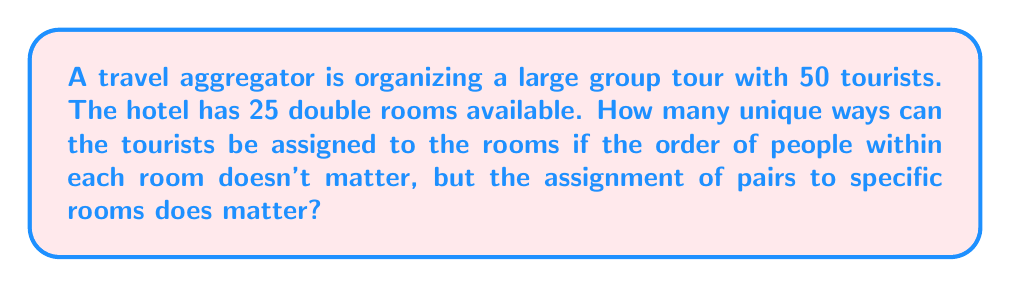Can you solve this math problem? Let's approach this step-by-step:

1) First, we need to determine how many ways we can pair up the 50 tourists. This is equivalent to choosing 25 pairs from 50 people.

2) To calculate this, we use the following formula:
   $$\frac{50!}{(2!)^{25} \cdot 25!}$$

   Where:
   - 50! represents all possible arrangements of 50 people
   - $(2!)^{25}$ accounts for the fact that the order within each pair doesn't matter
   - 25! accounts for the fact that the order of selecting the pairs doesn't matter

3) Next, we need to consider that these 25 pairs can be assigned to the 25 rooms in 25! ways.

4) Therefore, the total number of unique assignments is:

   $$\frac{50!}{(2!)^{25} \cdot 25!} \cdot 25!$$

5) This simplifies to:

   $$\frac{50!}{(2!)^{25}}$$

6) Calculating this:
   
   $$\frac{50!}{(2)^{25}} = 7.04 \times 10^{47}$$

This enormous number represents the total number of unique ways to assign 50 tourists to 25 double rooms, considering the specified conditions.
Answer: $7.04 \times 10^{47}$ 